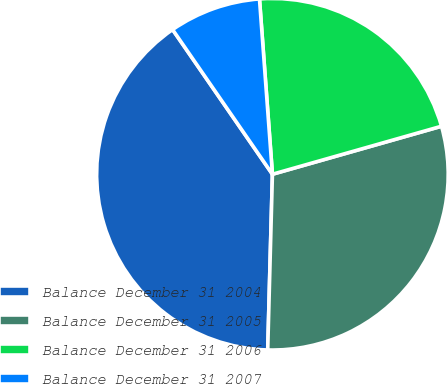Convert chart to OTSL. <chart><loc_0><loc_0><loc_500><loc_500><pie_chart><fcel>Balance December 31 2004<fcel>Balance December 31 2005<fcel>Balance December 31 2006<fcel>Balance December 31 2007<nl><fcel>39.96%<fcel>29.83%<fcel>21.77%<fcel>8.44%<nl></chart> 